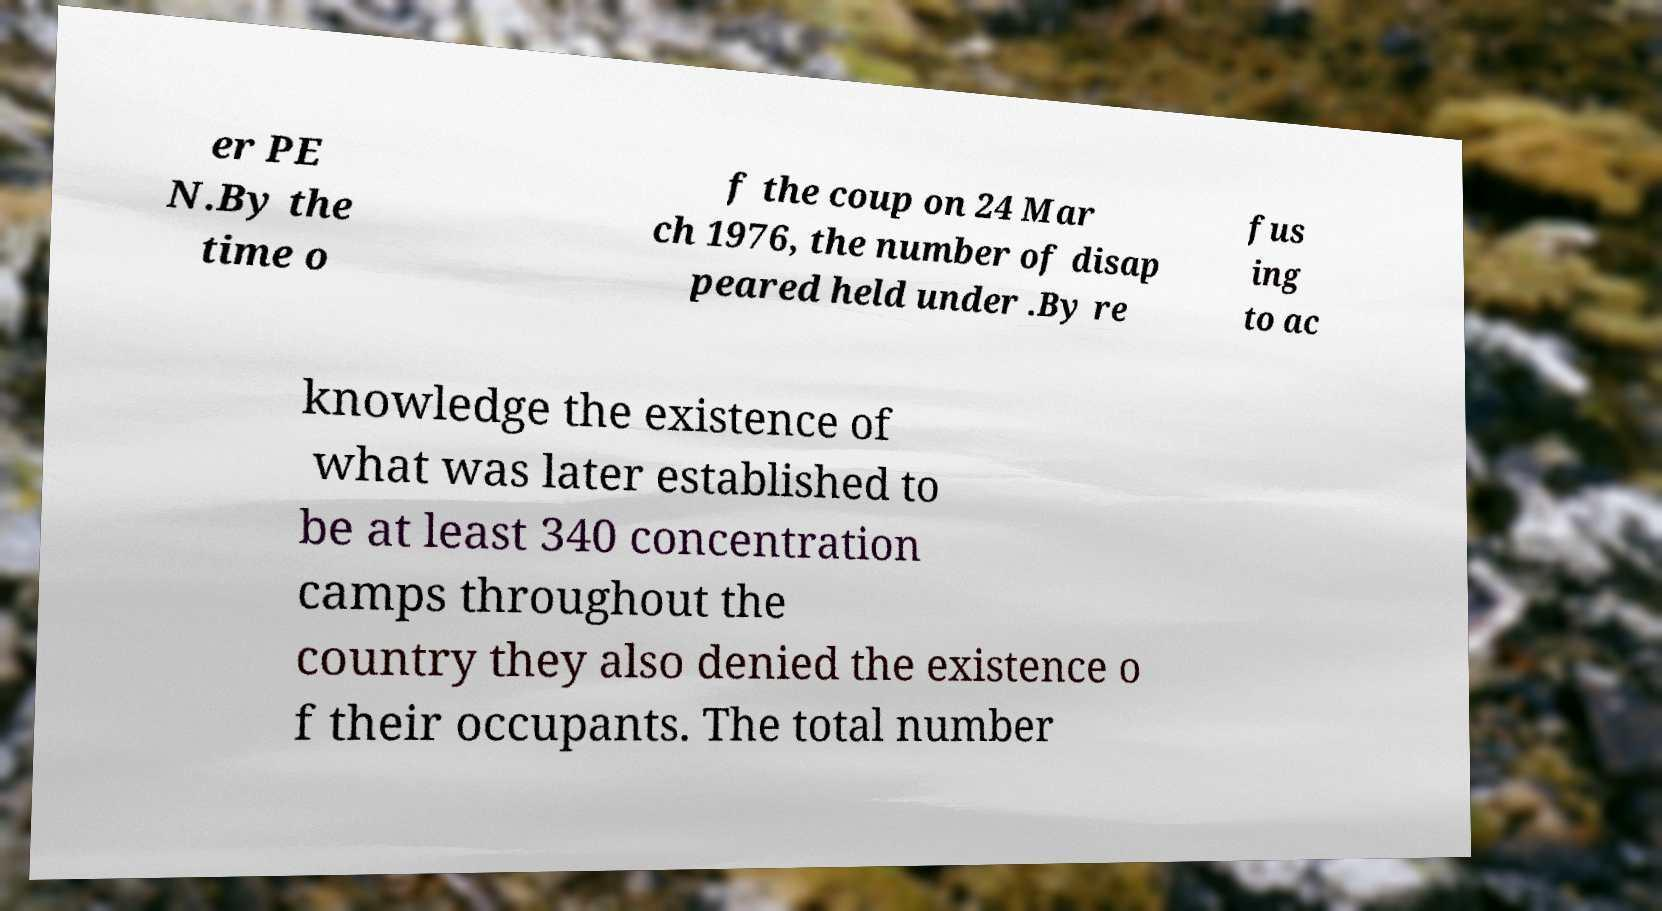I need the written content from this picture converted into text. Can you do that? er PE N.By the time o f the coup on 24 Mar ch 1976, the number of disap peared held under .By re fus ing to ac knowledge the existence of what was later established to be at least 340 concentration camps throughout the country they also denied the existence o f their occupants. The total number 